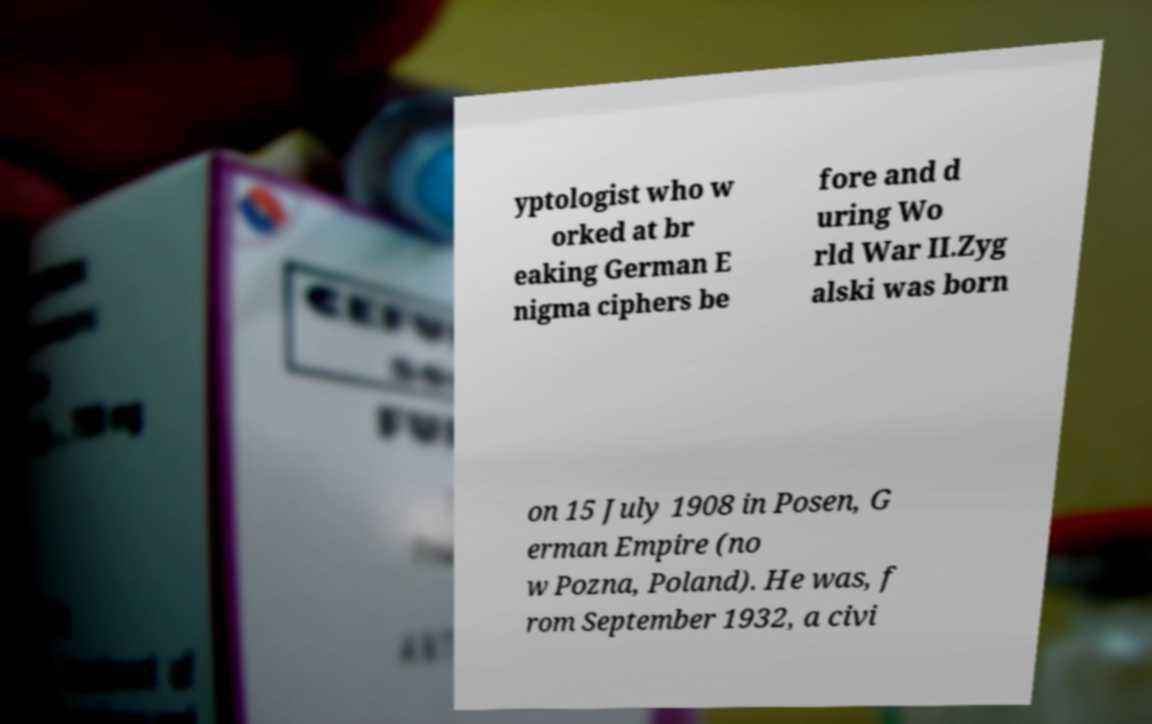Please read and relay the text visible in this image. What does it say? yptologist who w orked at br eaking German E nigma ciphers be fore and d uring Wo rld War II.Zyg alski was born on 15 July 1908 in Posen, G erman Empire (no w Pozna, Poland). He was, f rom September 1932, a civi 